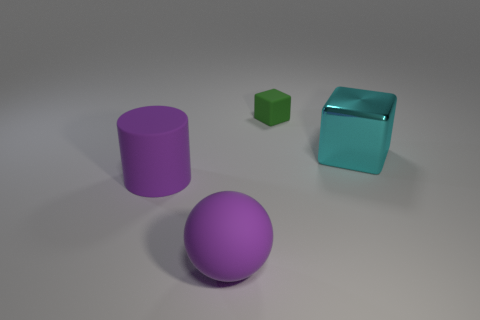What purpose do you think these objects serve? The objects in the image appear to be simple geometric shapes, suggesting they could be used for educational purposes, such as teaching geometry or color theory, or they could be decorative items meant to add a modern aesthetic to a space. 